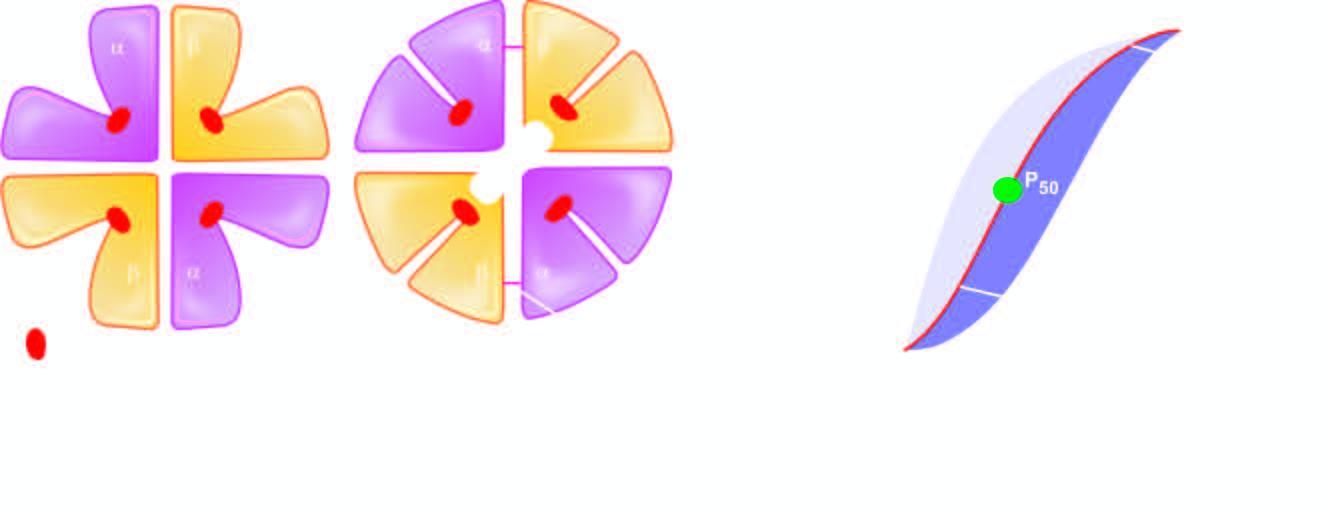what are expelled?
Answer the question using a single word or phrase. 2 